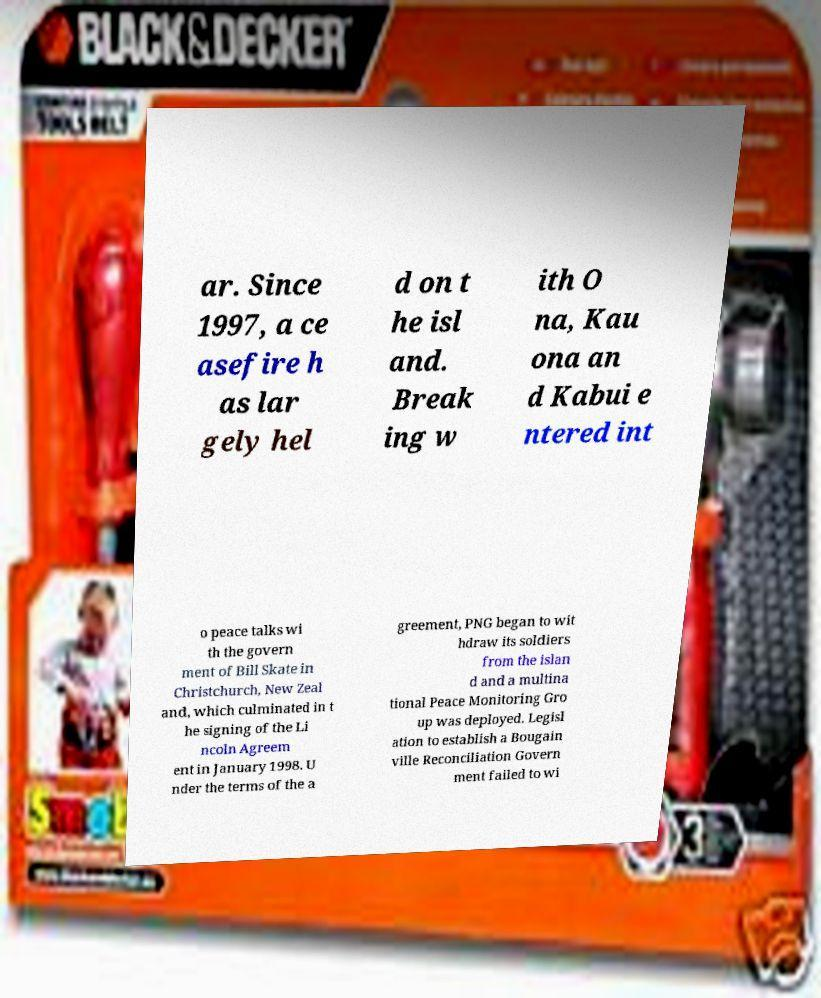Please identify and transcribe the text found in this image. ar. Since 1997, a ce asefire h as lar gely hel d on t he isl and. Break ing w ith O na, Kau ona an d Kabui e ntered int o peace talks wi th the govern ment of Bill Skate in Christchurch, New Zeal and, which culminated in t he signing of the Li ncoln Agreem ent in January 1998. U nder the terms of the a greement, PNG began to wit hdraw its soldiers from the islan d and a multina tional Peace Monitoring Gro up was deployed. Legisl ation to establish a Bougain ville Reconciliation Govern ment failed to wi 